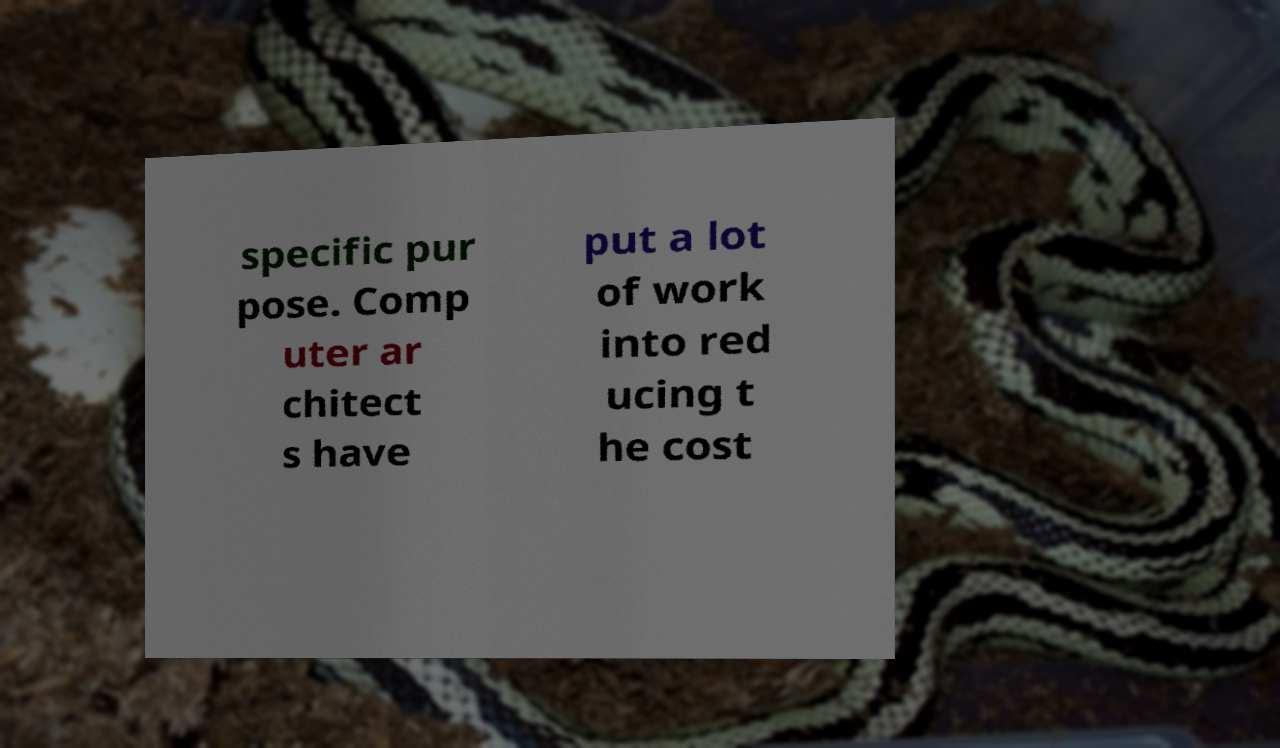Can you read and provide the text displayed in the image?This photo seems to have some interesting text. Can you extract and type it out for me? specific pur pose. Comp uter ar chitect s have put a lot of work into red ucing t he cost 